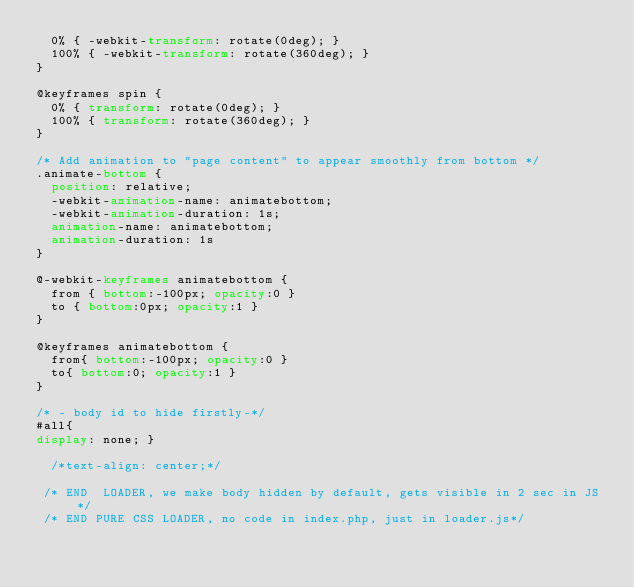Convert code to text. <code><loc_0><loc_0><loc_500><loc_500><_CSS_>  0% { -webkit-transform: rotate(0deg); }
  100% { -webkit-transform: rotate(360deg); }
}

@keyframes spin {
  0% { transform: rotate(0deg); }
  100% { transform: rotate(360deg); }
}

/* Add animation to "page content" to appear smoothly from bottom */
.animate-bottom {
  position: relative;
  -webkit-animation-name: animatebottom;
  -webkit-animation-duration: 1s;
  animation-name: animatebottom;
  animation-duration: 1s
}

@-webkit-keyframes animatebottom {
  from { bottom:-100px; opacity:0 } 
  to { bottom:0px; opacity:1 }
}

@keyframes animatebottom { 
  from{ bottom:-100px; opacity:0 } 
  to{ bottom:0; opacity:1 }
}

/* - body id to hide firstly-*/
#all{
display: none; }

  /*text-align: center;*/
  
 /* END  LOADER, we make body hidden by default, gets visible in 2 sec in JS */
 /* END PURE CSS LOADER, no code in index.php, just in loader.js*/</code> 